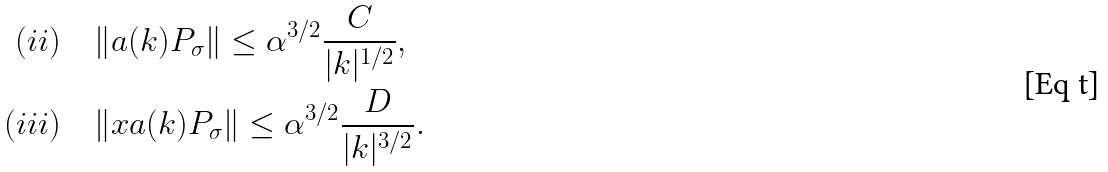<formula> <loc_0><loc_0><loc_500><loc_500>( i i ) \quad & \| a ( k ) P _ { \sigma } \| \leq \alpha ^ { 3 / 2 } \frac { C } { | k | ^ { 1 / 2 } } , \\ ( i i i ) \quad & \| x a ( k ) P _ { \sigma } \| \leq \alpha ^ { 3 / 2 } \frac { D } { | k | ^ { 3 / 2 } } .</formula> 